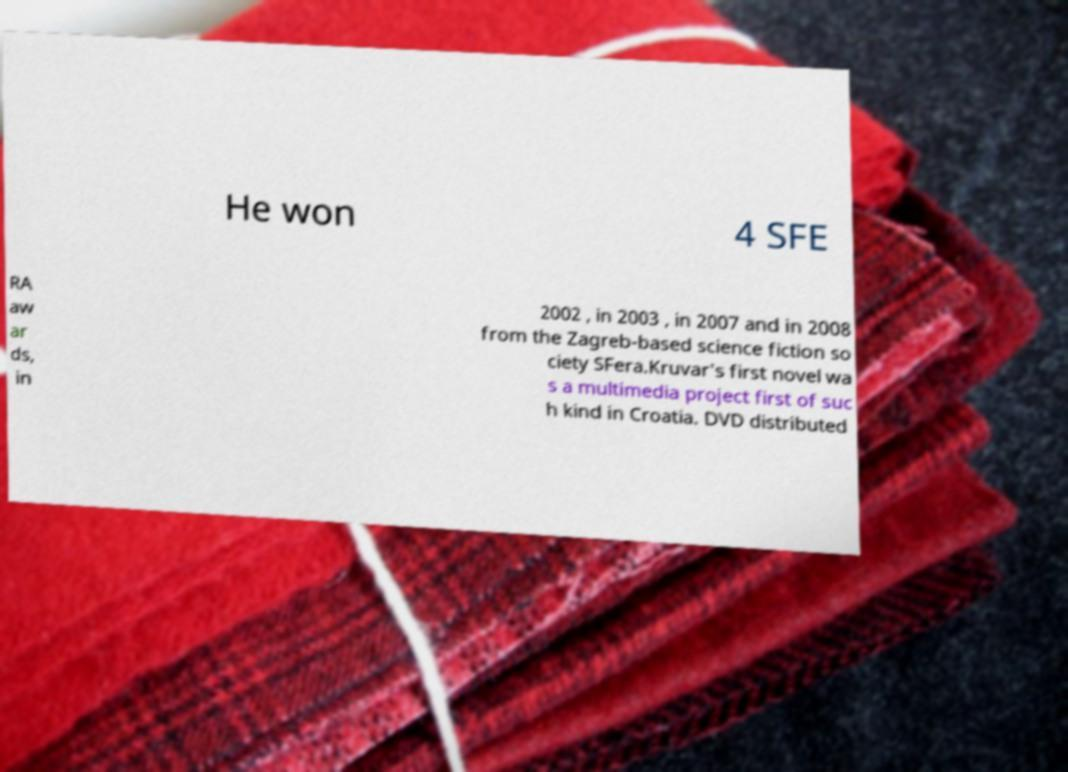What messages or text are displayed in this image? I need them in a readable, typed format. He won 4 SFE RA aw ar ds, in 2002 , in 2003 , in 2007 and in 2008 from the Zagreb-based science fiction so ciety SFera.Kruvar's first novel wa s a multimedia project first of suc h kind in Croatia. DVD distributed 